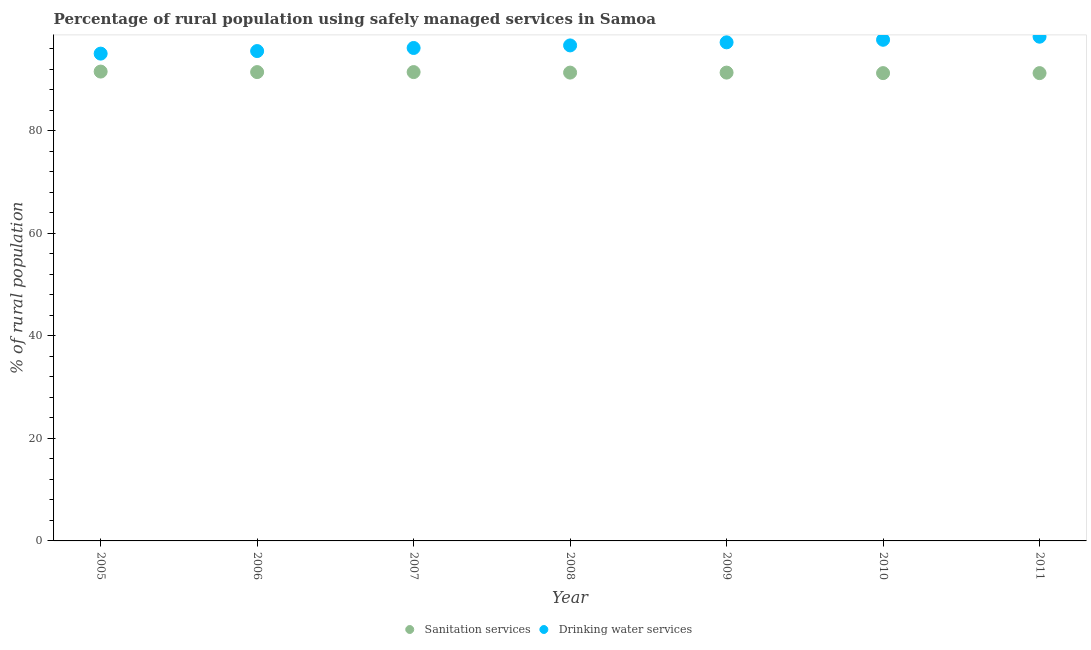Is the number of dotlines equal to the number of legend labels?
Offer a terse response. Yes. What is the percentage of rural population who used drinking water services in 2007?
Offer a very short reply. 96.1. Across all years, what is the maximum percentage of rural population who used drinking water services?
Provide a succinct answer. 98.3. Across all years, what is the minimum percentage of rural population who used sanitation services?
Your answer should be very brief. 91.2. In which year was the percentage of rural population who used drinking water services maximum?
Your response must be concise. 2011. In which year was the percentage of rural population who used sanitation services minimum?
Your answer should be very brief. 2010. What is the total percentage of rural population who used drinking water services in the graph?
Keep it short and to the point. 676.4. What is the difference between the percentage of rural population who used sanitation services in 2008 and that in 2010?
Ensure brevity in your answer.  0.1. What is the difference between the percentage of rural population who used drinking water services in 2007 and the percentage of rural population who used sanitation services in 2005?
Your answer should be very brief. 4.6. What is the average percentage of rural population who used sanitation services per year?
Provide a succinct answer. 91.33. In the year 2011, what is the difference between the percentage of rural population who used drinking water services and percentage of rural population who used sanitation services?
Provide a short and direct response. 7.1. What is the ratio of the percentage of rural population who used sanitation services in 2008 to that in 2011?
Ensure brevity in your answer.  1. Is the percentage of rural population who used sanitation services in 2008 less than that in 2010?
Provide a short and direct response. No. Is the difference between the percentage of rural population who used drinking water services in 2005 and 2010 greater than the difference between the percentage of rural population who used sanitation services in 2005 and 2010?
Give a very brief answer. No. What is the difference between the highest and the second highest percentage of rural population who used drinking water services?
Provide a short and direct response. 0.6. What is the difference between the highest and the lowest percentage of rural population who used drinking water services?
Give a very brief answer. 3.3. In how many years, is the percentage of rural population who used drinking water services greater than the average percentage of rural population who used drinking water services taken over all years?
Your answer should be very brief. 3. Is the sum of the percentage of rural population who used drinking water services in 2006 and 2007 greater than the maximum percentage of rural population who used sanitation services across all years?
Give a very brief answer. Yes. Does the percentage of rural population who used sanitation services monotonically increase over the years?
Your answer should be compact. No. Is the percentage of rural population who used drinking water services strictly greater than the percentage of rural population who used sanitation services over the years?
Your answer should be very brief. Yes. What is the difference between two consecutive major ticks on the Y-axis?
Provide a short and direct response. 20. Does the graph contain any zero values?
Keep it short and to the point. No. Where does the legend appear in the graph?
Your response must be concise. Bottom center. How are the legend labels stacked?
Provide a short and direct response. Horizontal. What is the title of the graph?
Offer a very short reply. Percentage of rural population using safely managed services in Samoa. What is the label or title of the Y-axis?
Make the answer very short. % of rural population. What is the % of rural population of Sanitation services in 2005?
Offer a very short reply. 91.5. What is the % of rural population of Sanitation services in 2006?
Provide a short and direct response. 91.4. What is the % of rural population in Drinking water services in 2006?
Your answer should be compact. 95.5. What is the % of rural population of Sanitation services in 2007?
Your answer should be compact. 91.4. What is the % of rural population in Drinking water services in 2007?
Your response must be concise. 96.1. What is the % of rural population of Sanitation services in 2008?
Ensure brevity in your answer.  91.3. What is the % of rural population of Drinking water services in 2008?
Give a very brief answer. 96.6. What is the % of rural population in Sanitation services in 2009?
Offer a terse response. 91.3. What is the % of rural population in Drinking water services in 2009?
Ensure brevity in your answer.  97.2. What is the % of rural population in Sanitation services in 2010?
Your response must be concise. 91.2. What is the % of rural population of Drinking water services in 2010?
Keep it short and to the point. 97.7. What is the % of rural population of Sanitation services in 2011?
Provide a succinct answer. 91.2. What is the % of rural population of Drinking water services in 2011?
Your response must be concise. 98.3. Across all years, what is the maximum % of rural population in Sanitation services?
Keep it short and to the point. 91.5. Across all years, what is the maximum % of rural population in Drinking water services?
Offer a terse response. 98.3. Across all years, what is the minimum % of rural population in Sanitation services?
Provide a succinct answer. 91.2. Across all years, what is the minimum % of rural population of Drinking water services?
Your answer should be compact. 95. What is the total % of rural population in Sanitation services in the graph?
Your answer should be compact. 639.3. What is the total % of rural population in Drinking water services in the graph?
Make the answer very short. 676.4. What is the difference between the % of rural population of Sanitation services in 2005 and that in 2007?
Make the answer very short. 0.1. What is the difference between the % of rural population of Sanitation services in 2005 and that in 2009?
Ensure brevity in your answer.  0.2. What is the difference between the % of rural population in Sanitation services in 2005 and that in 2011?
Provide a short and direct response. 0.3. What is the difference between the % of rural population of Sanitation services in 2006 and that in 2007?
Your response must be concise. 0. What is the difference between the % of rural population of Drinking water services in 2006 and that in 2007?
Give a very brief answer. -0.6. What is the difference between the % of rural population in Sanitation services in 2006 and that in 2008?
Offer a very short reply. 0.1. What is the difference between the % of rural population in Drinking water services in 2006 and that in 2008?
Give a very brief answer. -1.1. What is the difference between the % of rural population in Drinking water services in 2006 and that in 2010?
Give a very brief answer. -2.2. What is the difference between the % of rural population of Sanitation services in 2006 and that in 2011?
Your answer should be very brief. 0.2. What is the difference between the % of rural population in Drinking water services in 2006 and that in 2011?
Give a very brief answer. -2.8. What is the difference between the % of rural population of Sanitation services in 2007 and that in 2008?
Give a very brief answer. 0.1. What is the difference between the % of rural population in Drinking water services in 2007 and that in 2008?
Offer a terse response. -0.5. What is the difference between the % of rural population of Drinking water services in 2007 and that in 2009?
Provide a succinct answer. -1.1. What is the difference between the % of rural population in Sanitation services in 2007 and that in 2010?
Your response must be concise. 0.2. What is the difference between the % of rural population of Drinking water services in 2007 and that in 2010?
Provide a short and direct response. -1.6. What is the difference between the % of rural population in Drinking water services in 2007 and that in 2011?
Offer a terse response. -2.2. What is the difference between the % of rural population of Drinking water services in 2008 and that in 2009?
Offer a terse response. -0.6. What is the difference between the % of rural population of Sanitation services in 2008 and that in 2010?
Keep it short and to the point. 0.1. What is the difference between the % of rural population in Drinking water services in 2008 and that in 2011?
Make the answer very short. -1.7. What is the difference between the % of rural population of Sanitation services in 2009 and that in 2011?
Make the answer very short. 0.1. What is the difference between the % of rural population in Sanitation services in 2005 and the % of rural population in Drinking water services in 2006?
Provide a succinct answer. -4. What is the difference between the % of rural population in Sanitation services in 2005 and the % of rural population in Drinking water services in 2009?
Your answer should be very brief. -5.7. What is the difference between the % of rural population in Sanitation services in 2005 and the % of rural population in Drinking water services in 2011?
Keep it short and to the point. -6.8. What is the difference between the % of rural population of Sanitation services in 2006 and the % of rural population of Drinking water services in 2007?
Give a very brief answer. -4.7. What is the difference between the % of rural population of Sanitation services in 2006 and the % of rural population of Drinking water services in 2011?
Offer a terse response. -6.9. What is the difference between the % of rural population in Sanitation services in 2007 and the % of rural population in Drinking water services in 2008?
Your answer should be very brief. -5.2. What is the difference between the % of rural population of Sanitation services in 2007 and the % of rural population of Drinking water services in 2010?
Your response must be concise. -6.3. What is the difference between the % of rural population of Sanitation services in 2007 and the % of rural population of Drinking water services in 2011?
Your response must be concise. -6.9. What is the average % of rural population in Sanitation services per year?
Provide a succinct answer. 91.33. What is the average % of rural population of Drinking water services per year?
Provide a short and direct response. 96.63. In the year 2009, what is the difference between the % of rural population in Sanitation services and % of rural population in Drinking water services?
Make the answer very short. -5.9. In the year 2010, what is the difference between the % of rural population of Sanitation services and % of rural population of Drinking water services?
Your answer should be very brief. -6.5. What is the ratio of the % of rural population in Sanitation services in 2005 to that in 2006?
Make the answer very short. 1. What is the ratio of the % of rural population in Drinking water services in 2005 to that in 2006?
Offer a very short reply. 0.99. What is the ratio of the % of rural population in Sanitation services in 2005 to that in 2007?
Give a very brief answer. 1. What is the ratio of the % of rural population of Sanitation services in 2005 to that in 2008?
Ensure brevity in your answer.  1. What is the ratio of the % of rural population in Drinking water services in 2005 to that in 2008?
Provide a succinct answer. 0.98. What is the ratio of the % of rural population in Drinking water services in 2005 to that in 2009?
Provide a succinct answer. 0.98. What is the ratio of the % of rural population of Drinking water services in 2005 to that in 2010?
Ensure brevity in your answer.  0.97. What is the ratio of the % of rural population in Drinking water services in 2005 to that in 2011?
Provide a succinct answer. 0.97. What is the ratio of the % of rural population of Sanitation services in 2006 to that in 2008?
Make the answer very short. 1. What is the ratio of the % of rural population in Drinking water services in 2006 to that in 2008?
Make the answer very short. 0.99. What is the ratio of the % of rural population in Sanitation services in 2006 to that in 2009?
Keep it short and to the point. 1. What is the ratio of the % of rural population in Drinking water services in 2006 to that in 2009?
Provide a succinct answer. 0.98. What is the ratio of the % of rural population of Drinking water services in 2006 to that in 2010?
Make the answer very short. 0.98. What is the ratio of the % of rural population of Sanitation services in 2006 to that in 2011?
Give a very brief answer. 1. What is the ratio of the % of rural population of Drinking water services in 2006 to that in 2011?
Your answer should be very brief. 0.97. What is the ratio of the % of rural population of Sanitation services in 2007 to that in 2008?
Your answer should be very brief. 1. What is the ratio of the % of rural population in Drinking water services in 2007 to that in 2008?
Give a very brief answer. 0.99. What is the ratio of the % of rural population of Drinking water services in 2007 to that in 2009?
Ensure brevity in your answer.  0.99. What is the ratio of the % of rural population of Sanitation services in 2007 to that in 2010?
Your response must be concise. 1. What is the ratio of the % of rural population in Drinking water services in 2007 to that in 2010?
Give a very brief answer. 0.98. What is the ratio of the % of rural population in Sanitation services in 2007 to that in 2011?
Keep it short and to the point. 1. What is the ratio of the % of rural population in Drinking water services in 2007 to that in 2011?
Ensure brevity in your answer.  0.98. What is the ratio of the % of rural population of Sanitation services in 2008 to that in 2009?
Make the answer very short. 1. What is the ratio of the % of rural population of Drinking water services in 2008 to that in 2009?
Provide a succinct answer. 0.99. What is the ratio of the % of rural population of Sanitation services in 2008 to that in 2010?
Offer a very short reply. 1. What is the ratio of the % of rural population of Drinking water services in 2008 to that in 2010?
Provide a short and direct response. 0.99. What is the ratio of the % of rural population in Drinking water services in 2008 to that in 2011?
Offer a terse response. 0.98. What is the ratio of the % of rural population in Sanitation services in 2009 to that in 2010?
Ensure brevity in your answer.  1. What is the ratio of the % of rural population of Drinking water services in 2009 to that in 2010?
Provide a short and direct response. 0.99. What is the ratio of the % of rural population in Sanitation services in 2009 to that in 2011?
Ensure brevity in your answer.  1. What is the ratio of the % of rural population in Drinking water services in 2010 to that in 2011?
Ensure brevity in your answer.  0.99. What is the difference between the highest and the second highest % of rural population in Sanitation services?
Provide a short and direct response. 0.1. What is the difference between the highest and the second highest % of rural population of Drinking water services?
Ensure brevity in your answer.  0.6. What is the difference between the highest and the lowest % of rural population in Sanitation services?
Keep it short and to the point. 0.3. What is the difference between the highest and the lowest % of rural population of Drinking water services?
Ensure brevity in your answer.  3.3. 